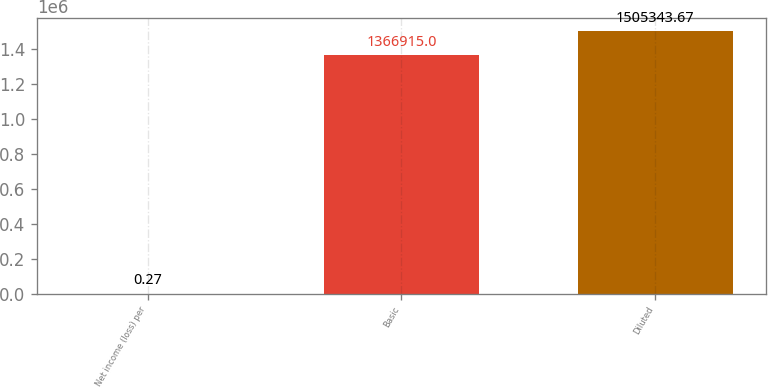Convert chart to OTSL. <chart><loc_0><loc_0><loc_500><loc_500><bar_chart><fcel>Net income (loss) per<fcel>Basic<fcel>Diluted<nl><fcel>0.27<fcel>1.36692e+06<fcel>1.50534e+06<nl></chart> 